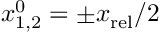Convert formula to latex. <formula><loc_0><loc_0><loc_500><loc_500>x _ { 1 , 2 } ^ { 0 } = \pm x _ { r e l } / 2</formula> 